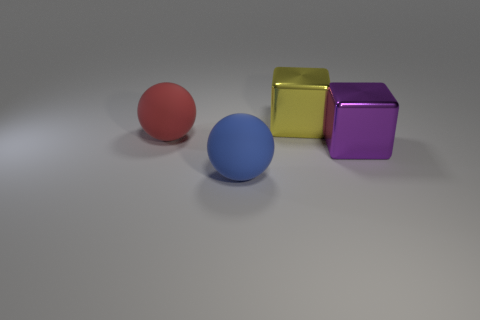What number of metallic things are either big purple things or large green cylinders?
Ensure brevity in your answer.  1. There is a large purple thing that is the same material as the big yellow block; what shape is it?
Provide a short and direct response. Cube. What number of large things are both on the left side of the purple metal cube and right of the blue ball?
Your answer should be very brief. 1. Is there anything else that is the same shape as the large purple thing?
Provide a short and direct response. Yes. How big is the rubber ball that is behind the blue rubber ball?
Provide a short and direct response. Large. The sphere that is in front of the rubber ball on the left side of the blue thing is made of what material?
Give a very brief answer. Rubber. How many other big yellow things have the same shape as the big yellow thing?
Your answer should be compact. 0. Is there a thing in front of the big purple object that is on the right side of the blue ball to the right of the big red rubber thing?
Provide a short and direct response. Yes. How many yellow blocks are the same size as the blue ball?
Ensure brevity in your answer.  1. What is the shape of the purple thing?
Give a very brief answer. Cube. 